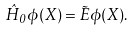<formula> <loc_0><loc_0><loc_500><loc_500>\hat { H } _ { 0 } \phi ( X ) = \tilde { E } \phi ( X ) .</formula> 